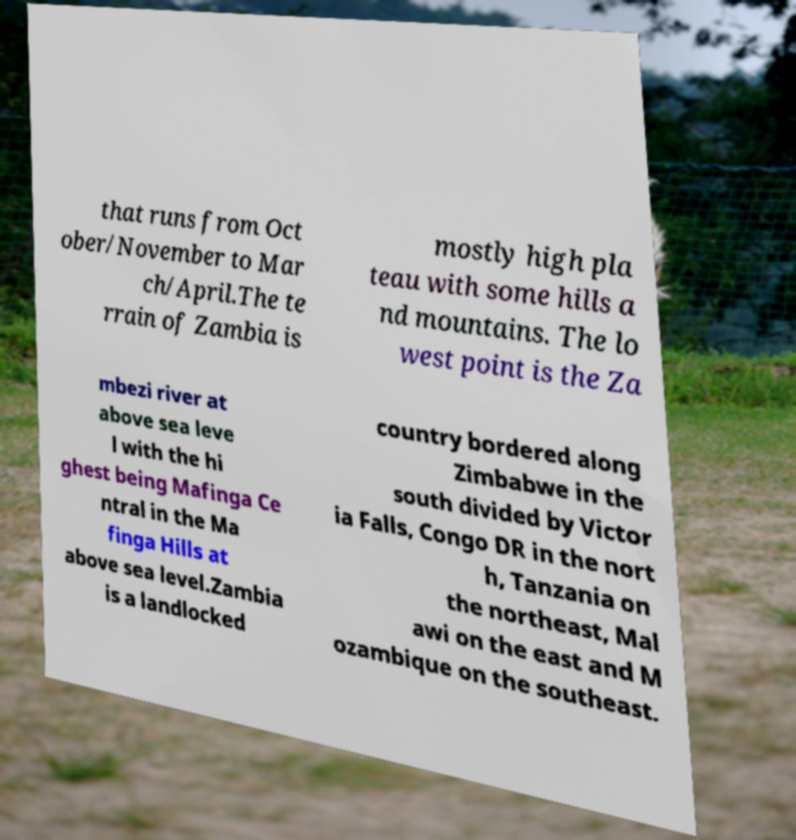For documentation purposes, I need the text within this image transcribed. Could you provide that? that runs from Oct ober/November to Mar ch/April.The te rrain of Zambia is mostly high pla teau with some hills a nd mountains. The lo west point is the Za mbezi river at above sea leve l with the hi ghest being Mafinga Ce ntral in the Ma finga Hills at above sea level.Zambia is a landlocked country bordered along Zimbabwe in the south divided by Victor ia Falls, Congo DR in the nort h, Tanzania on the northeast, Mal awi on the east and M ozambique on the southeast. 